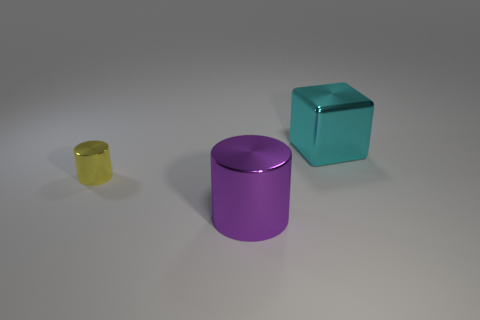Add 3 yellow metallic cylinders. How many objects exist? 6 Subtract all cylinders. How many objects are left? 1 Subtract all big brown metal objects. Subtract all yellow metallic cylinders. How many objects are left? 2 Add 1 metal cylinders. How many metal cylinders are left? 3 Add 2 tiny rubber cylinders. How many tiny rubber cylinders exist? 2 Subtract 1 purple cylinders. How many objects are left? 2 